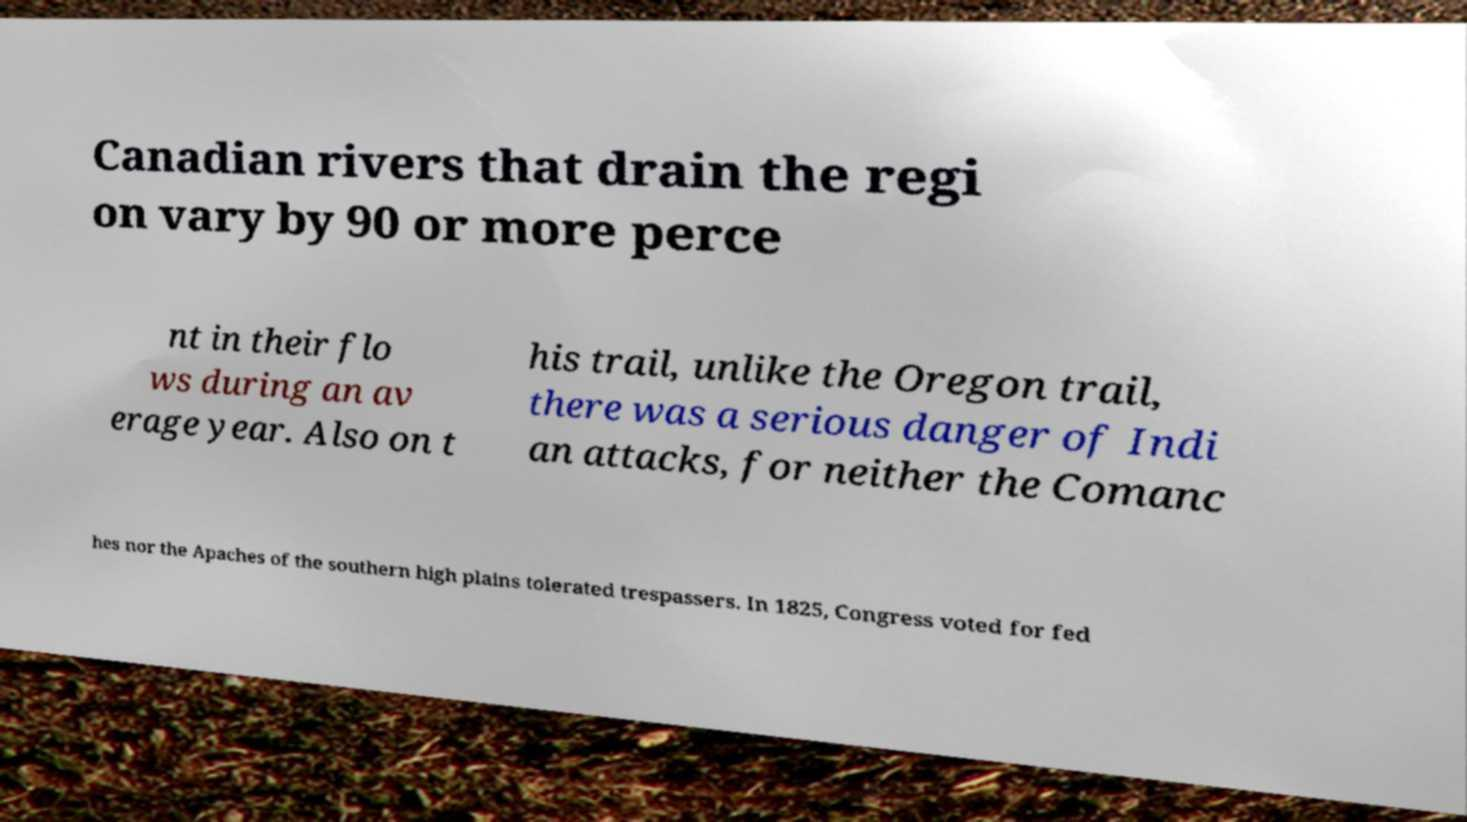I need the written content from this picture converted into text. Can you do that? Canadian rivers that drain the regi on vary by 90 or more perce nt in their flo ws during an av erage year. Also on t his trail, unlike the Oregon trail, there was a serious danger of Indi an attacks, for neither the Comanc hes nor the Apaches of the southern high plains tolerated trespassers. In 1825, Congress voted for fed 